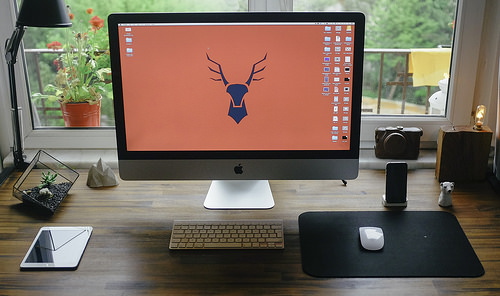<image>
Can you confirm if the tablet is in front of the lamp? Yes. The tablet is positioned in front of the lamp, appearing closer to the camera viewpoint. 